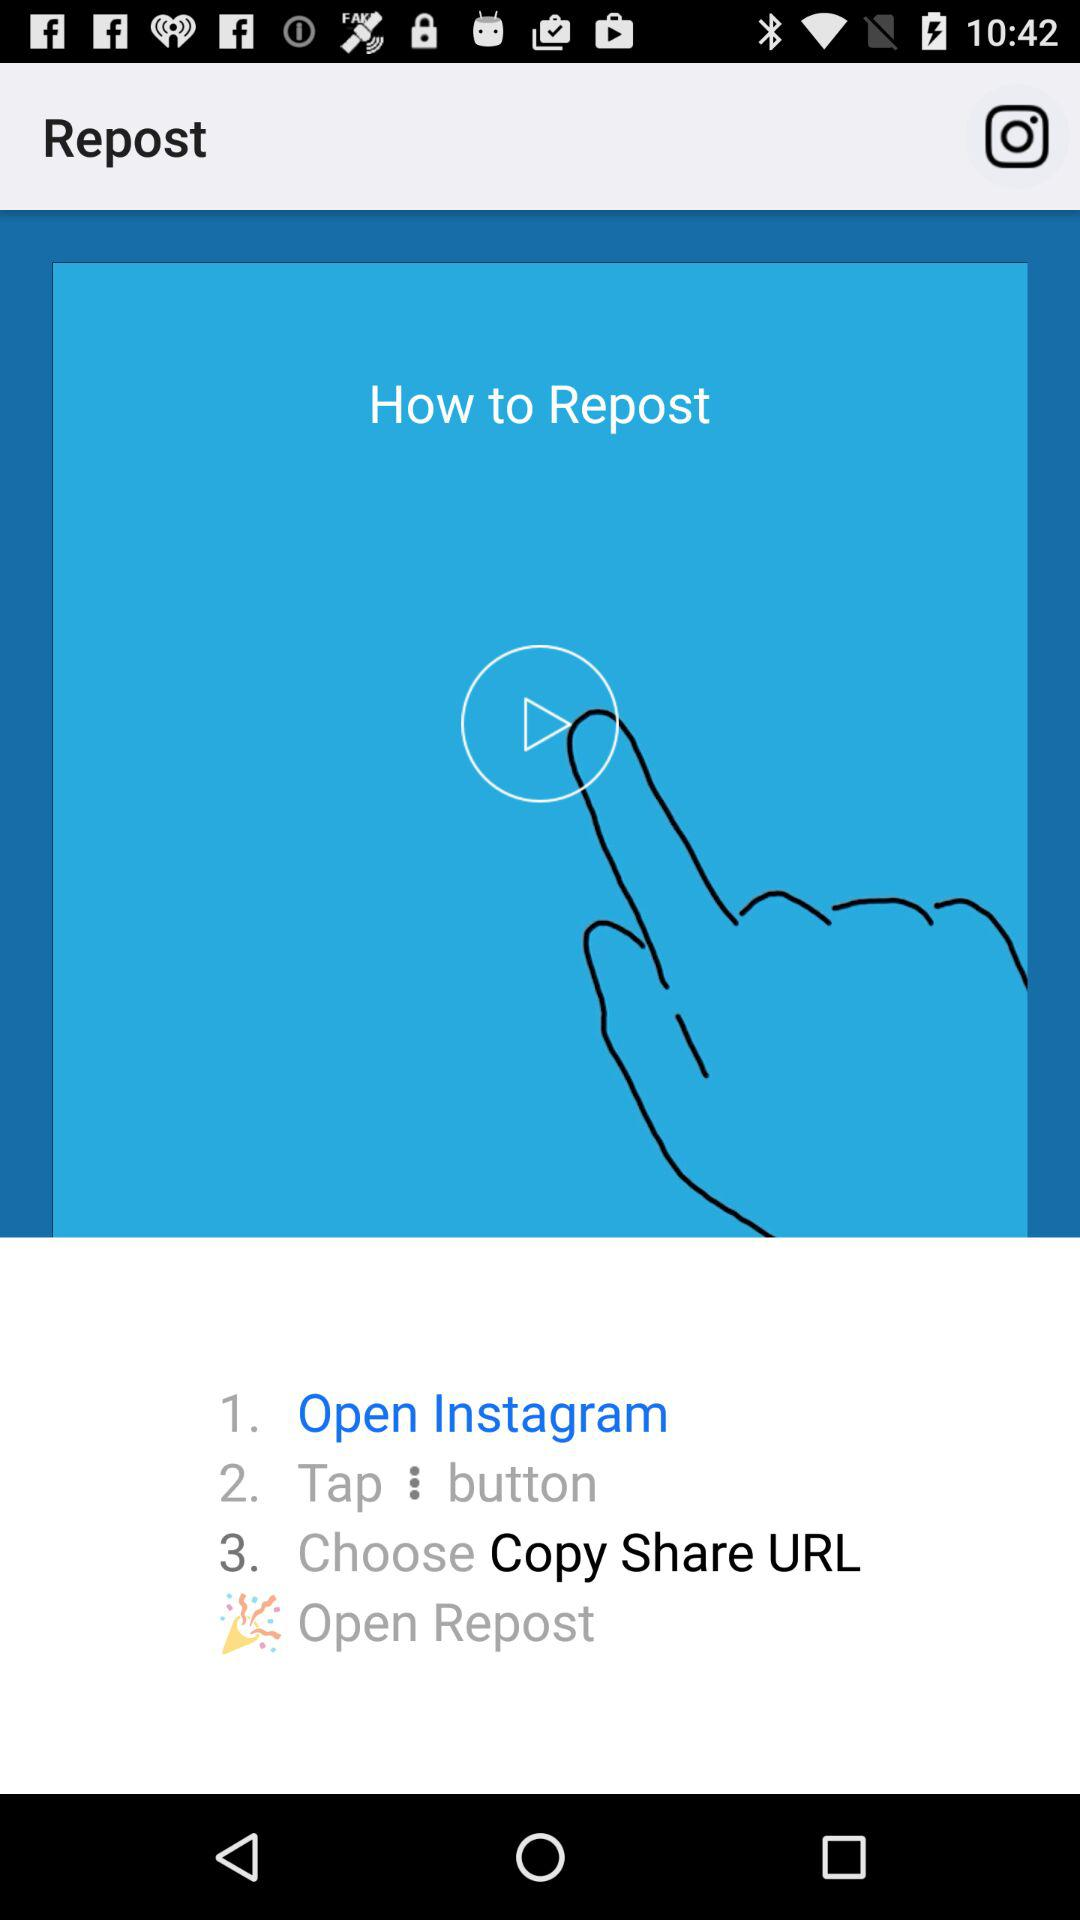How many steps are there in the process of reposting a photo on Instagram?
Answer the question using a single word or phrase. 3 